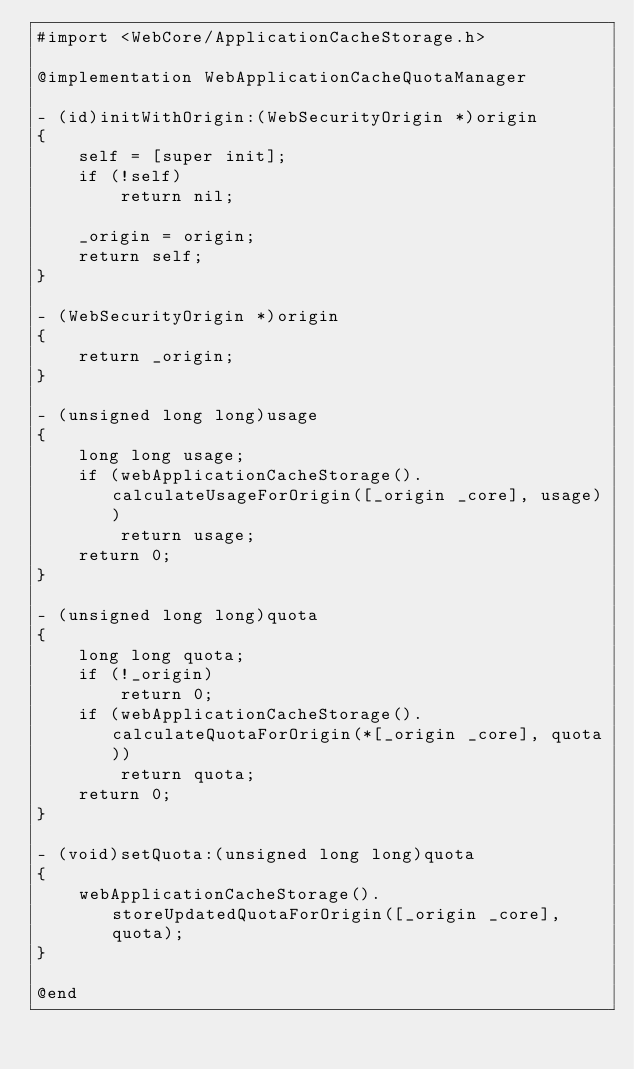Convert code to text. <code><loc_0><loc_0><loc_500><loc_500><_ObjectiveC_>#import <WebCore/ApplicationCacheStorage.h>

@implementation WebApplicationCacheQuotaManager

- (id)initWithOrigin:(WebSecurityOrigin *)origin
{
    self = [super init];
    if (!self)
        return nil;

    _origin = origin;
    return self;
}

- (WebSecurityOrigin *)origin
{
    return _origin;
}

- (unsigned long long)usage
{
    long long usage;
    if (webApplicationCacheStorage().calculateUsageForOrigin([_origin _core], usage))
        return usage;
    return 0;
}

- (unsigned long long)quota
{
    long long quota;
    if (!_origin)
        return 0;
    if (webApplicationCacheStorage().calculateQuotaForOrigin(*[_origin _core], quota))
        return quota;
    return 0;
}

- (void)setQuota:(unsigned long long)quota
{
    webApplicationCacheStorage().storeUpdatedQuotaForOrigin([_origin _core], quota);
}

@end
</code> 